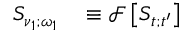Convert formula to latex. <formula><loc_0><loc_0><loc_500><loc_500>\begin{array} { r l } { S _ { \nu _ { 1 } ; \omega _ { 1 } } } & \equiv \ m a t h s c r { F } \left [ S _ { t ; t ^ { \prime } } \right ] } \end{array}</formula> 